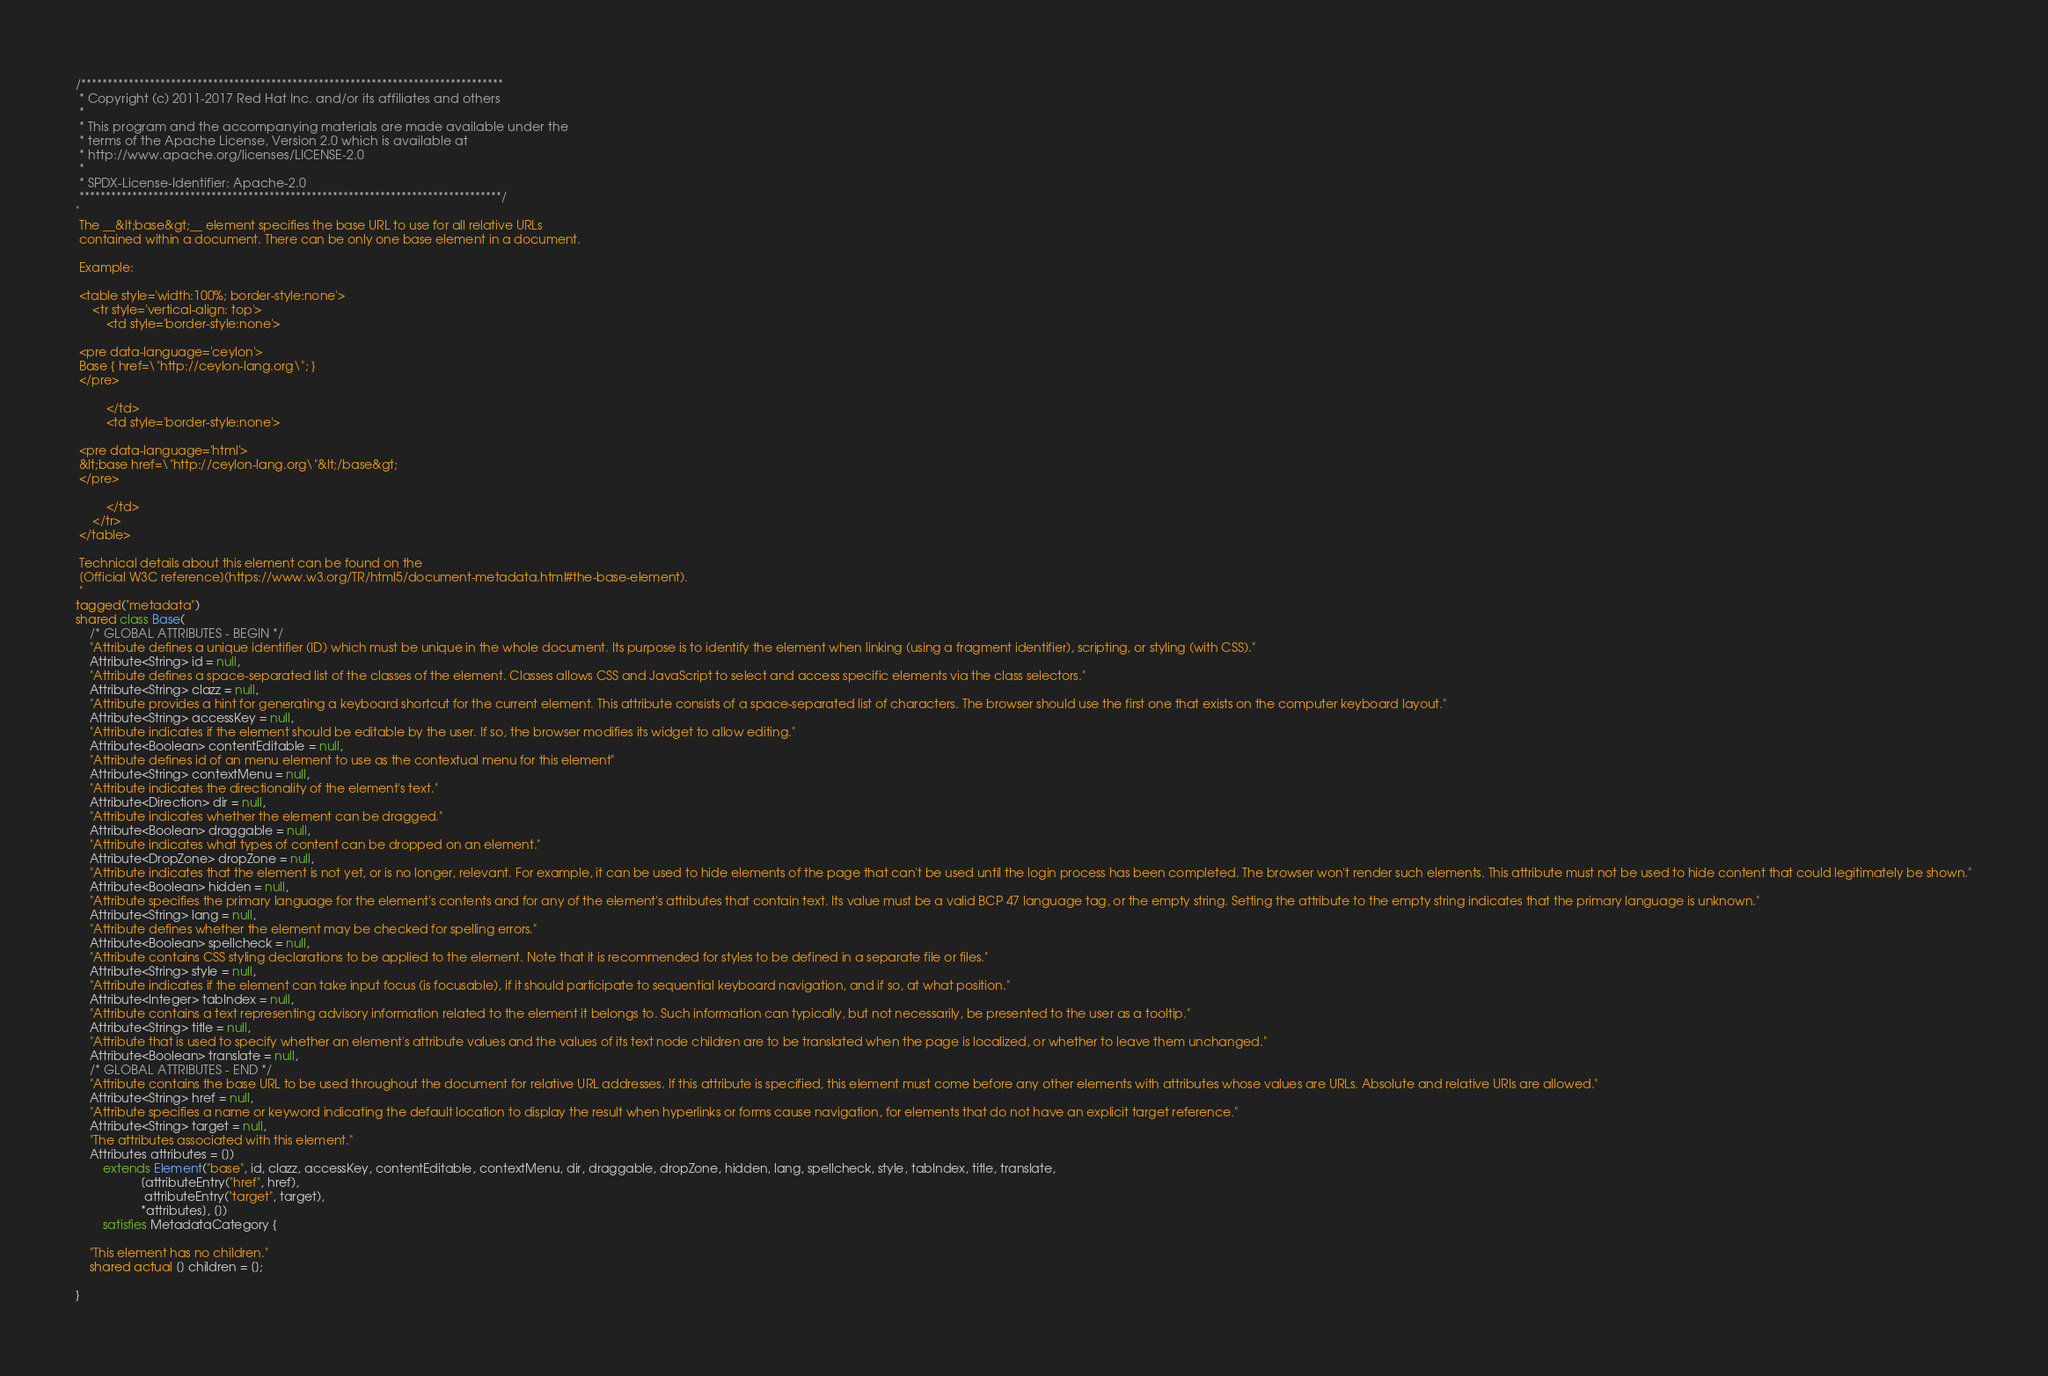Convert code to text. <code><loc_0><loc_0><loc_500><loc_500><_Ceylon_>/********************************************************************************
 * Copyright (c) 2011-2017 Red Hat Inc. and/or its affiliates and others
 *
 * This program and the accompanying materials are made available under the 
 * terms of the Apache License, Version 2.0 which is available at
 * http://www.apache.org/licenses/LICENSE-2.0
 *
 * SPDX-License-Identifier: Apache-2.0 
 ********************************************************************************/
"
 The __&lt;base&gt;__ element specifies the base URL to use for all relative URLs 
 contained within a document. There can be only one base element in a document.
 
 Example:
 
 <table style='width:100%; border-style:none'>
     <tr style='vertical-align: top'>
         <td style='border-style:none'>
         
 <pre data-language='ceylon'>
 Base { href=\"http://ceylon-lang.org\"; }
 </pre>
 
         </td>
         <td style='border-style:none'>
         
 <pre data-language='html'>
 &lt;base href=\"http://ceylon-lang.org\"&lt;/base&gt;
 </pre>
 
         </td>         
     </tr>
 </table>
 
 Technical details about this element can be found on the
 [Official W3C reference](https://www.w3.org/TR/html5/document-metadata.html#the-base-element).
 "
tagged("metadata")
shared class Base(
    /* GLOBAL ATTRIBUTES - BEGIN */
    "Attribute defines a unique identifier (ID) which must be unique in the whole document. Its purpose is to identify the element when linking (using a fragment identifier), scripting, or styling (with CSS)."
    Attribute<String> id = null,
    "Attribute defines a space-separated list of the classes of the element. Classes allows CSS and JavaScript to select and access specific elements via the class selectors."
    Attribute<String> clazz = null,
    "Attribute provides a hint for generating a keyboard shortcut for the current element. This attribute consists of a space-separated list of characters. The browser should use the first one that exists on the computer keyboard layout."
    Attribute<String> accessKey = null,
    "Attribute indicates if the element should be editable by the user. If so, the browser modifies its widget to allow editing."
    Attribute<Boolean> contentEditable = null,
    "Attribute defines id of an menu element to use as the contextual menu for this element"
    Attribute<String> contextMenu = null,
    "Attribute indicates the directionality of the element's text."
    Attribute<Direction> dir = null,
    "Attribute indicates whether the element can be dragged."
    Attribute<Boolean> draggable = null,
    "Attribute indicates what types of content can be dropped on an element."
    Attribute<DropZone> dropZone = null,
    "Attribute indicates that the element is not yet, or is no longer, relevant. For example, it can be used to hide elements of the page that can't be used until the login process has been completed. The browser won't render such elements. This attribute must not be used to hide content that could legitimately be shown."
    Attribute<Boolean> hidden = null,
    "Attribute specifies the primary language for the element's contents and for any of the element's attributes that contain text. Its value must be a valid BCP 47 language tag, or the empty string. Setting the attribute to the empty string indicates that the primary language is unknown."
    Attribute<String> lang = null,
    "Attribute defines whether the element may be checked for spelling errors."
    Attribute<Boolean> spellcheck = null,
    "Attribute contains CSS styling declarations to be applied to the element. Note that it is recommended for styles to be defined in a separate file or files."
    Attribute<String> style = null,
    "Attribute indicates if the element can take input focus (is focusable), if it should participate to sequential keyboard navigation, and if so, at what position."
    Attribute<Integer> tabIndex = null,
    "Attribute contains a text representing advisory information related to the element it belongs to. Such information can typically, but not necessarily, be presented to the user as a tooltip."
    Attribute<String> title = null,
    "Attribute that is used to specify whether an element's attribute values and the values of its text node children are to be translated when the page is localized, or whether to leave them unchanged."
    Attribute<Boolean> translate = null,
    /* GLOBAL ATTRIBUTES - END */
    "Attribute contains the base URL to be used throughout the document for relative URL addresses. If this attribute is specified, this element must come before any other elements with attributes whose values are URLs. Absolute and relative URIs are allowed."
    Attribute<String> href = null,
    "Attribute specifies a name or keyword indicating the default location to display the result when hyperlinks or forms cause navigation, for elements that do not have an explicit target reference."
    Attribute<String> target = null,
    "The attributes associated with this element."
    Attributes attributes = [])
        extends Element("base", id, clazz, accessKey, contentEditable, contextMenu, dir, draggable, dropZone, hidden, lang, spellcheck, style, tabIndex, title, translate, 
                   [attributeEntry("href", href), 
                    attributeEntry("target", target), 
                   *attributes], [])
        satisfies MetadataCategory {
    
    "This element has no children."
    shared actual [] children = [];
    
}</code> 